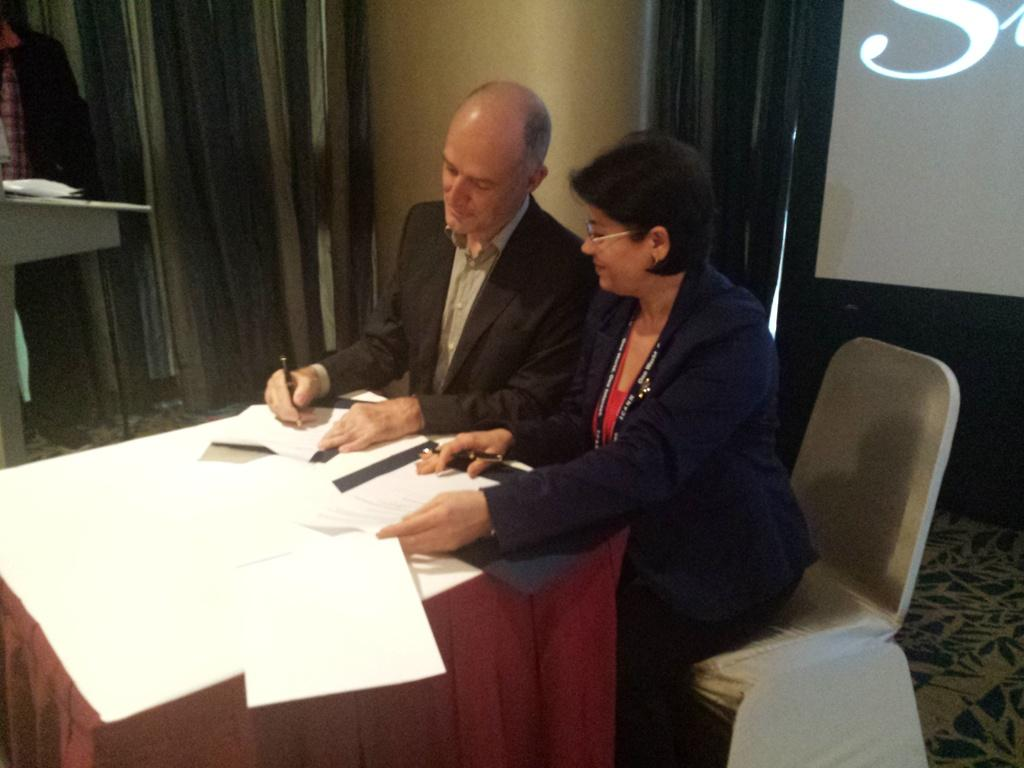What type of furniture can be seen in the image? There are chairs and tables in the image. What objects are on the tables? Papers are on the tables in the image. Who is present in the image? There are people in the image. What is the background of the image? There is a wall in the image, and curtains are present as well. How many girls are playing with the string in the image? There is no mention of girls or string in the image; it features chairs, tables, papers, people, a wall, and curtains. 